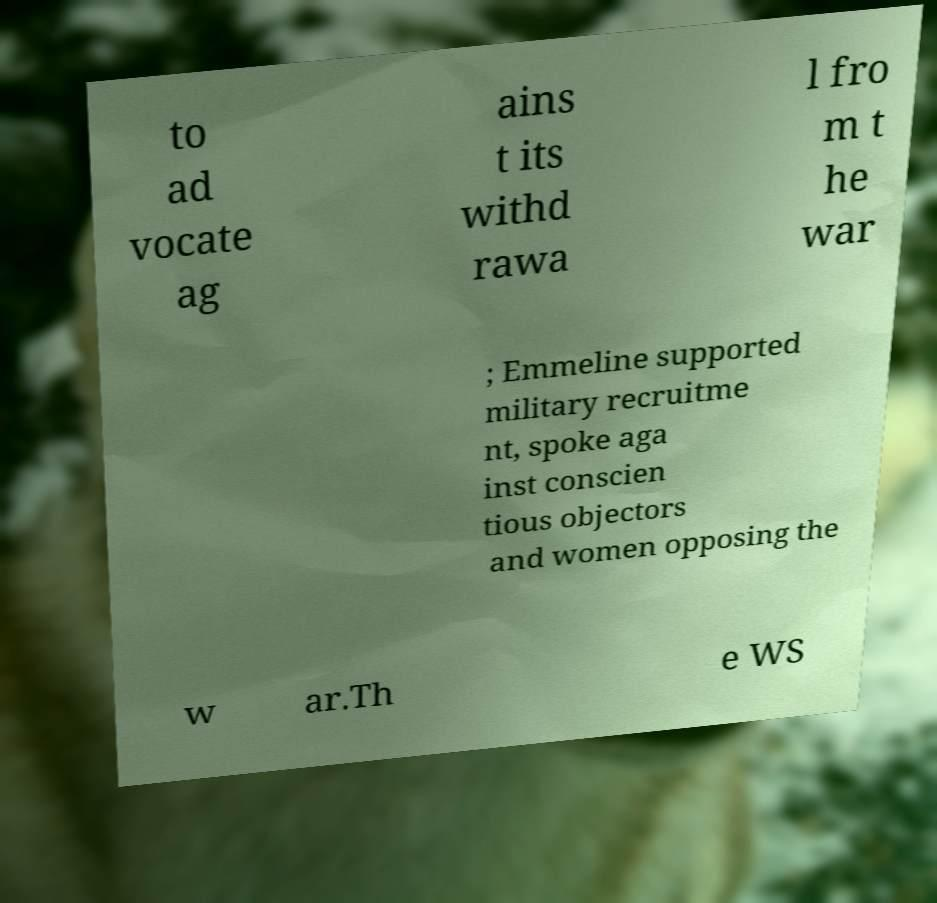Could you extract and type out the text from this image? to ad vocate ag ains t its withd rawa l fro m t he war ; Emmeline supported military recruitme nt, spoke aga inst conscien tious objectors and women opposing the w ar.Th e WS 